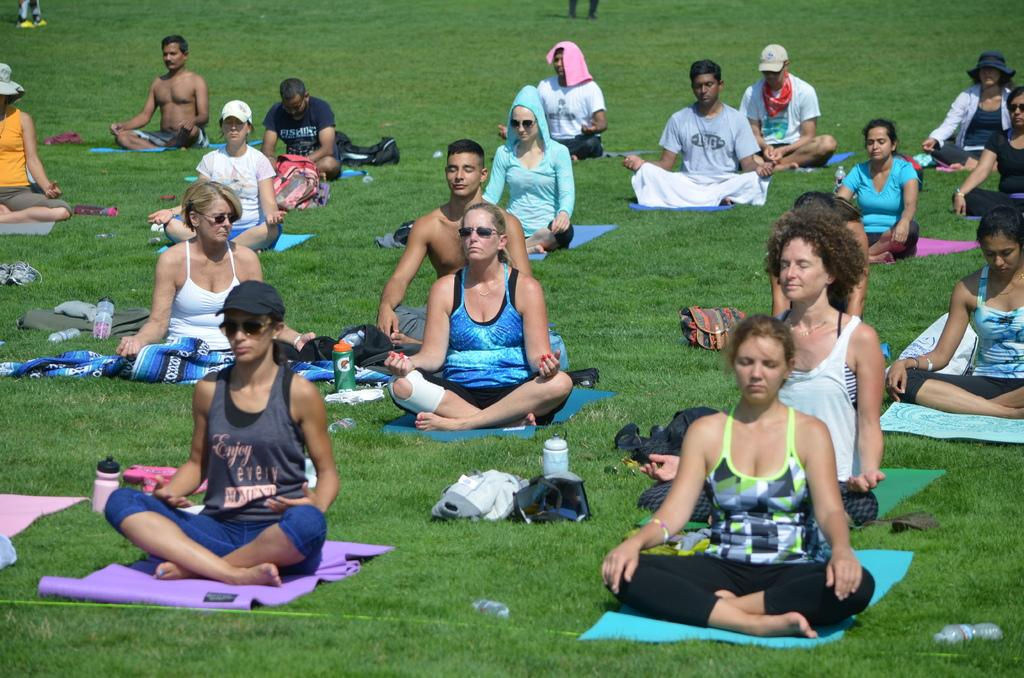How many people are in the image? There are many persons in the image. What are the persons in the image doing? The persons are sitting and doing yoga. What is the ground made of in the image? There is green grass at the bottom of the image. What items are used for practicing yoga in the image? Yoga mats are visible in the image. What type of potato is being cooked on the stove in the image? There is no stove or potato present in the image; it features a group of people doing yoga on green grass with yoga mats. 